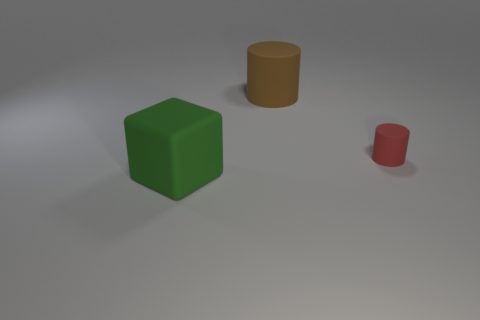Can you describe the shapes and colors of the objects shown in the image? Certainly! The image shows three geometric shapes. On the left there is a green cube, in the middle a large mustard yellow cylinder, and to the right a smaller cylinder which is crimson in color. They are placed on a light gray surface with a plain background. 